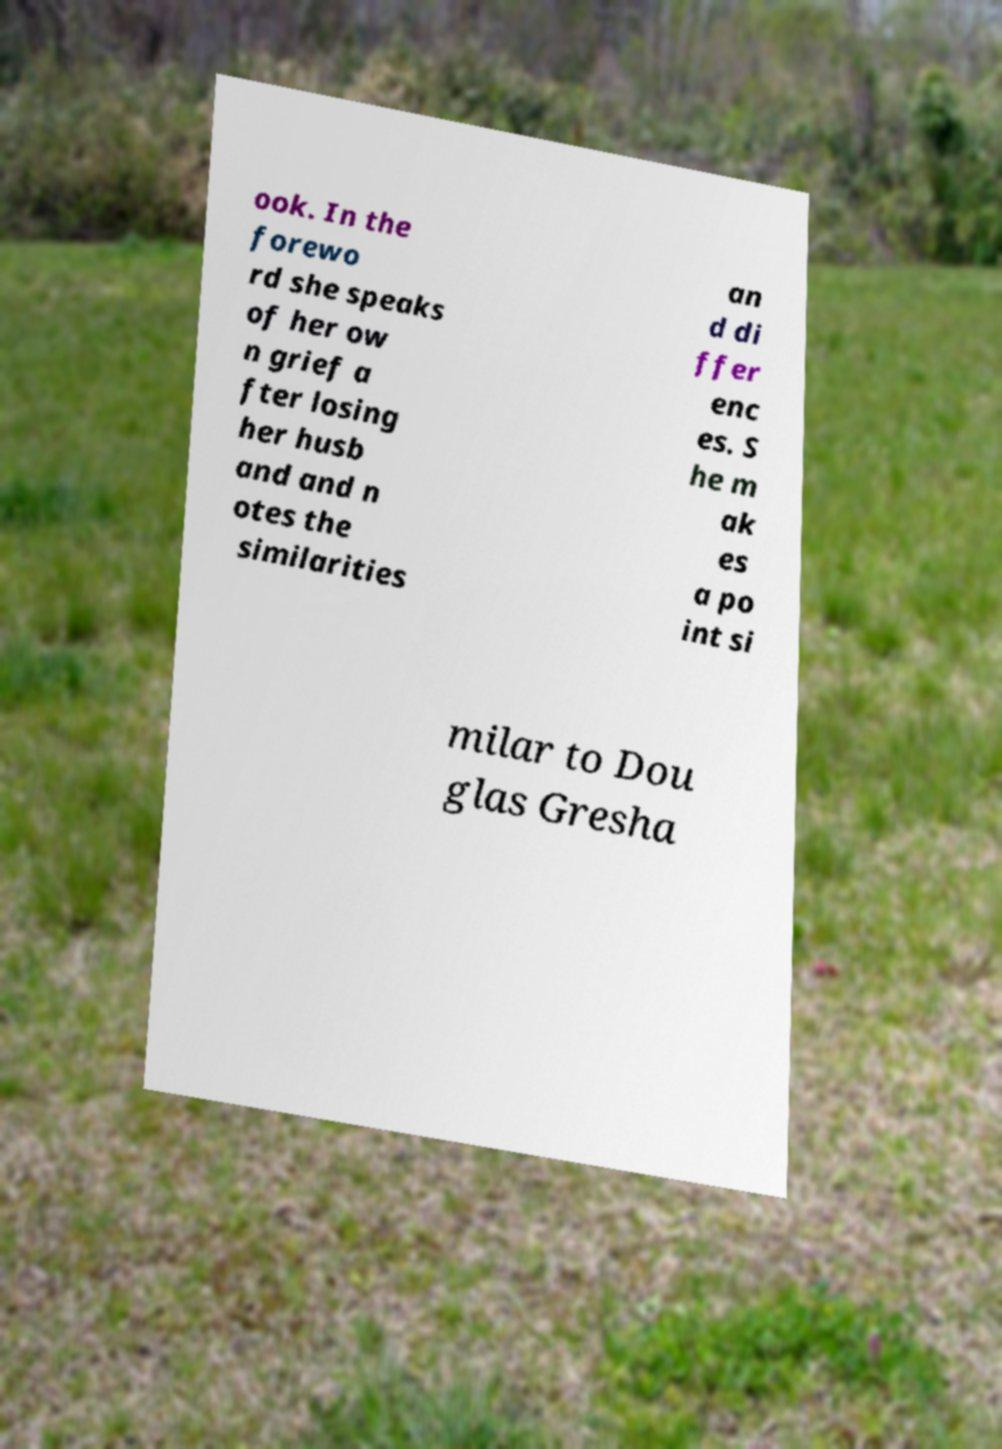Please identify and transcribe the text found in this image. ook. In the forewo rd she speaks of her ow n grief a fter losing her husb and and n otes the similarities an d di ffer enc es. S he m ak es a po int si milar to Dou glas Gresha 